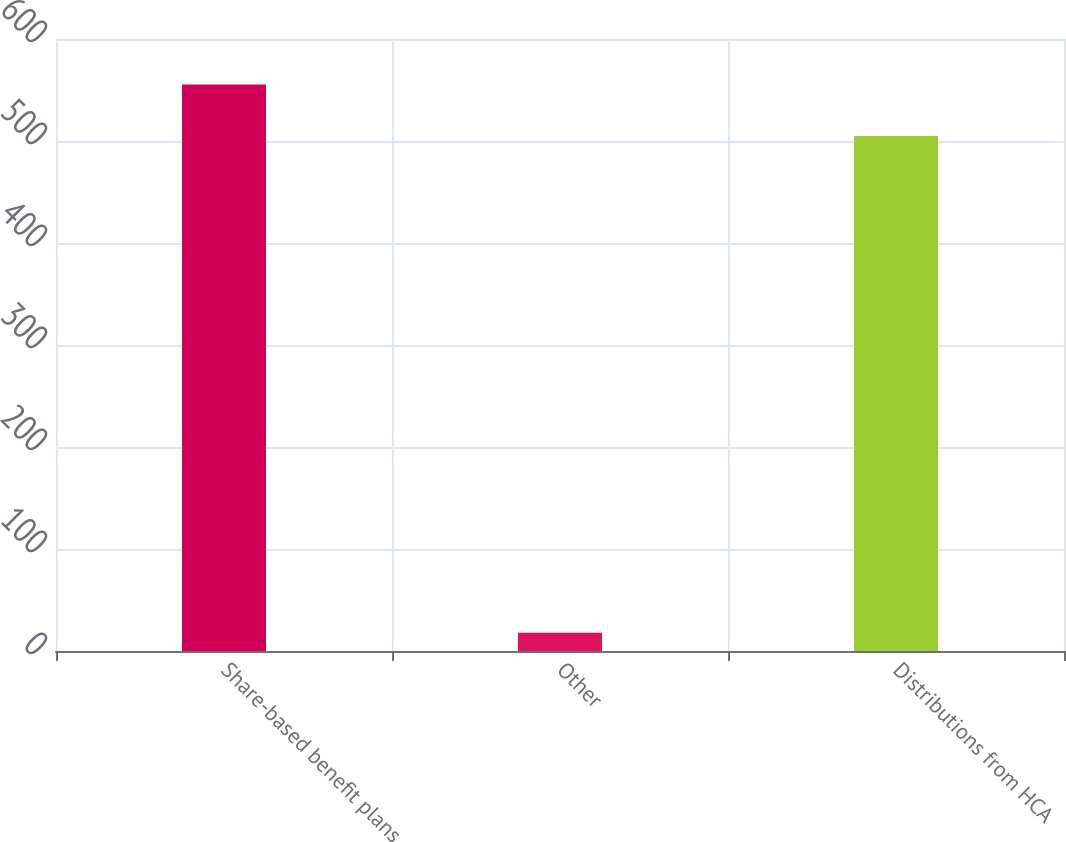Convert chart. <chart><loc_0><loc_0><loc_500><loc_500><bar_chart><fcel>Share-based benefit plans<fcel>Other<fcel>Distributions from HCA<nl><fcel>555.5<fcel>18<fcel>505<nl></chart> 